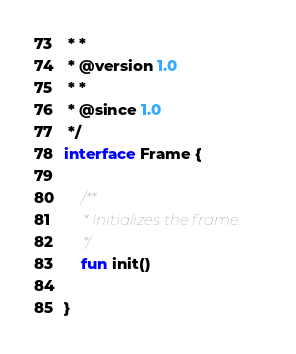Convert code to text. <code><loc_0><loc_0><loc_500><loc_500><_Kotlin_> * *
 * @version 1.0
 * *
 * @since 1.0
 */
interface Frame {

    /**
     * Initializes the frame.
     */
    fun init()

}
</code> 